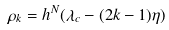Convert formula to latex. <formula><loc_0><loc_0><loc_500><loc_500>\rho _ { k } = h ^ { N } ( \lambda _ { c } - ( 2 k - 1 ) \eta )</formula> 